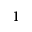Convert formula to latex. <formula><loc_0><loc_0><loc_500><loc_500>^ { 1 }</formula> 